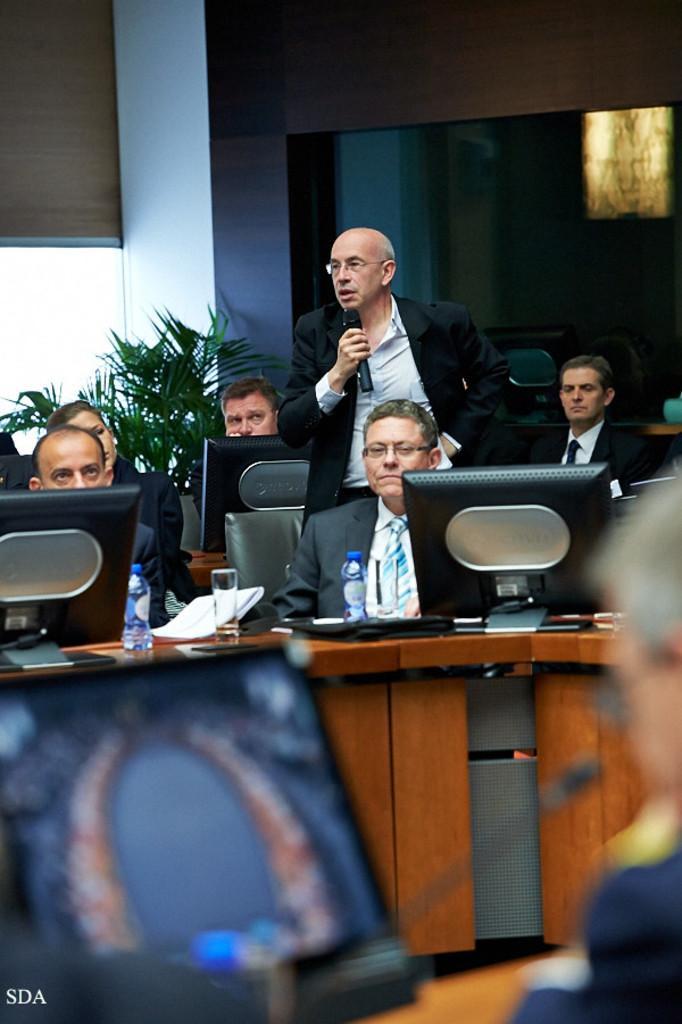Describe this image in one or two sentences. In this image we can see group of people sitting in front of monitors. One person is standing wearing spectacles and holding a microphone in his hand. In the background we can see a plant and a window. 